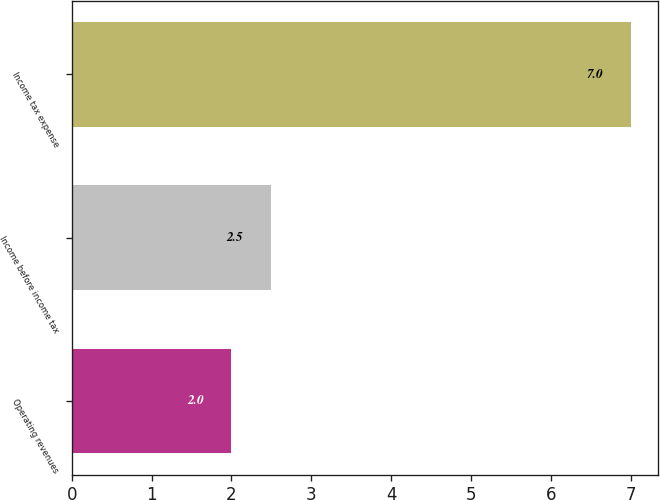<chart> <loc_0><loc_0><loc_500><loc_500><bar_chart><fcel>Operating revenues<fcel>Income before income tax<fcel>Income tax expense<nl><fcel>2<fcel>2.5<fcel>7<nl></chart> 